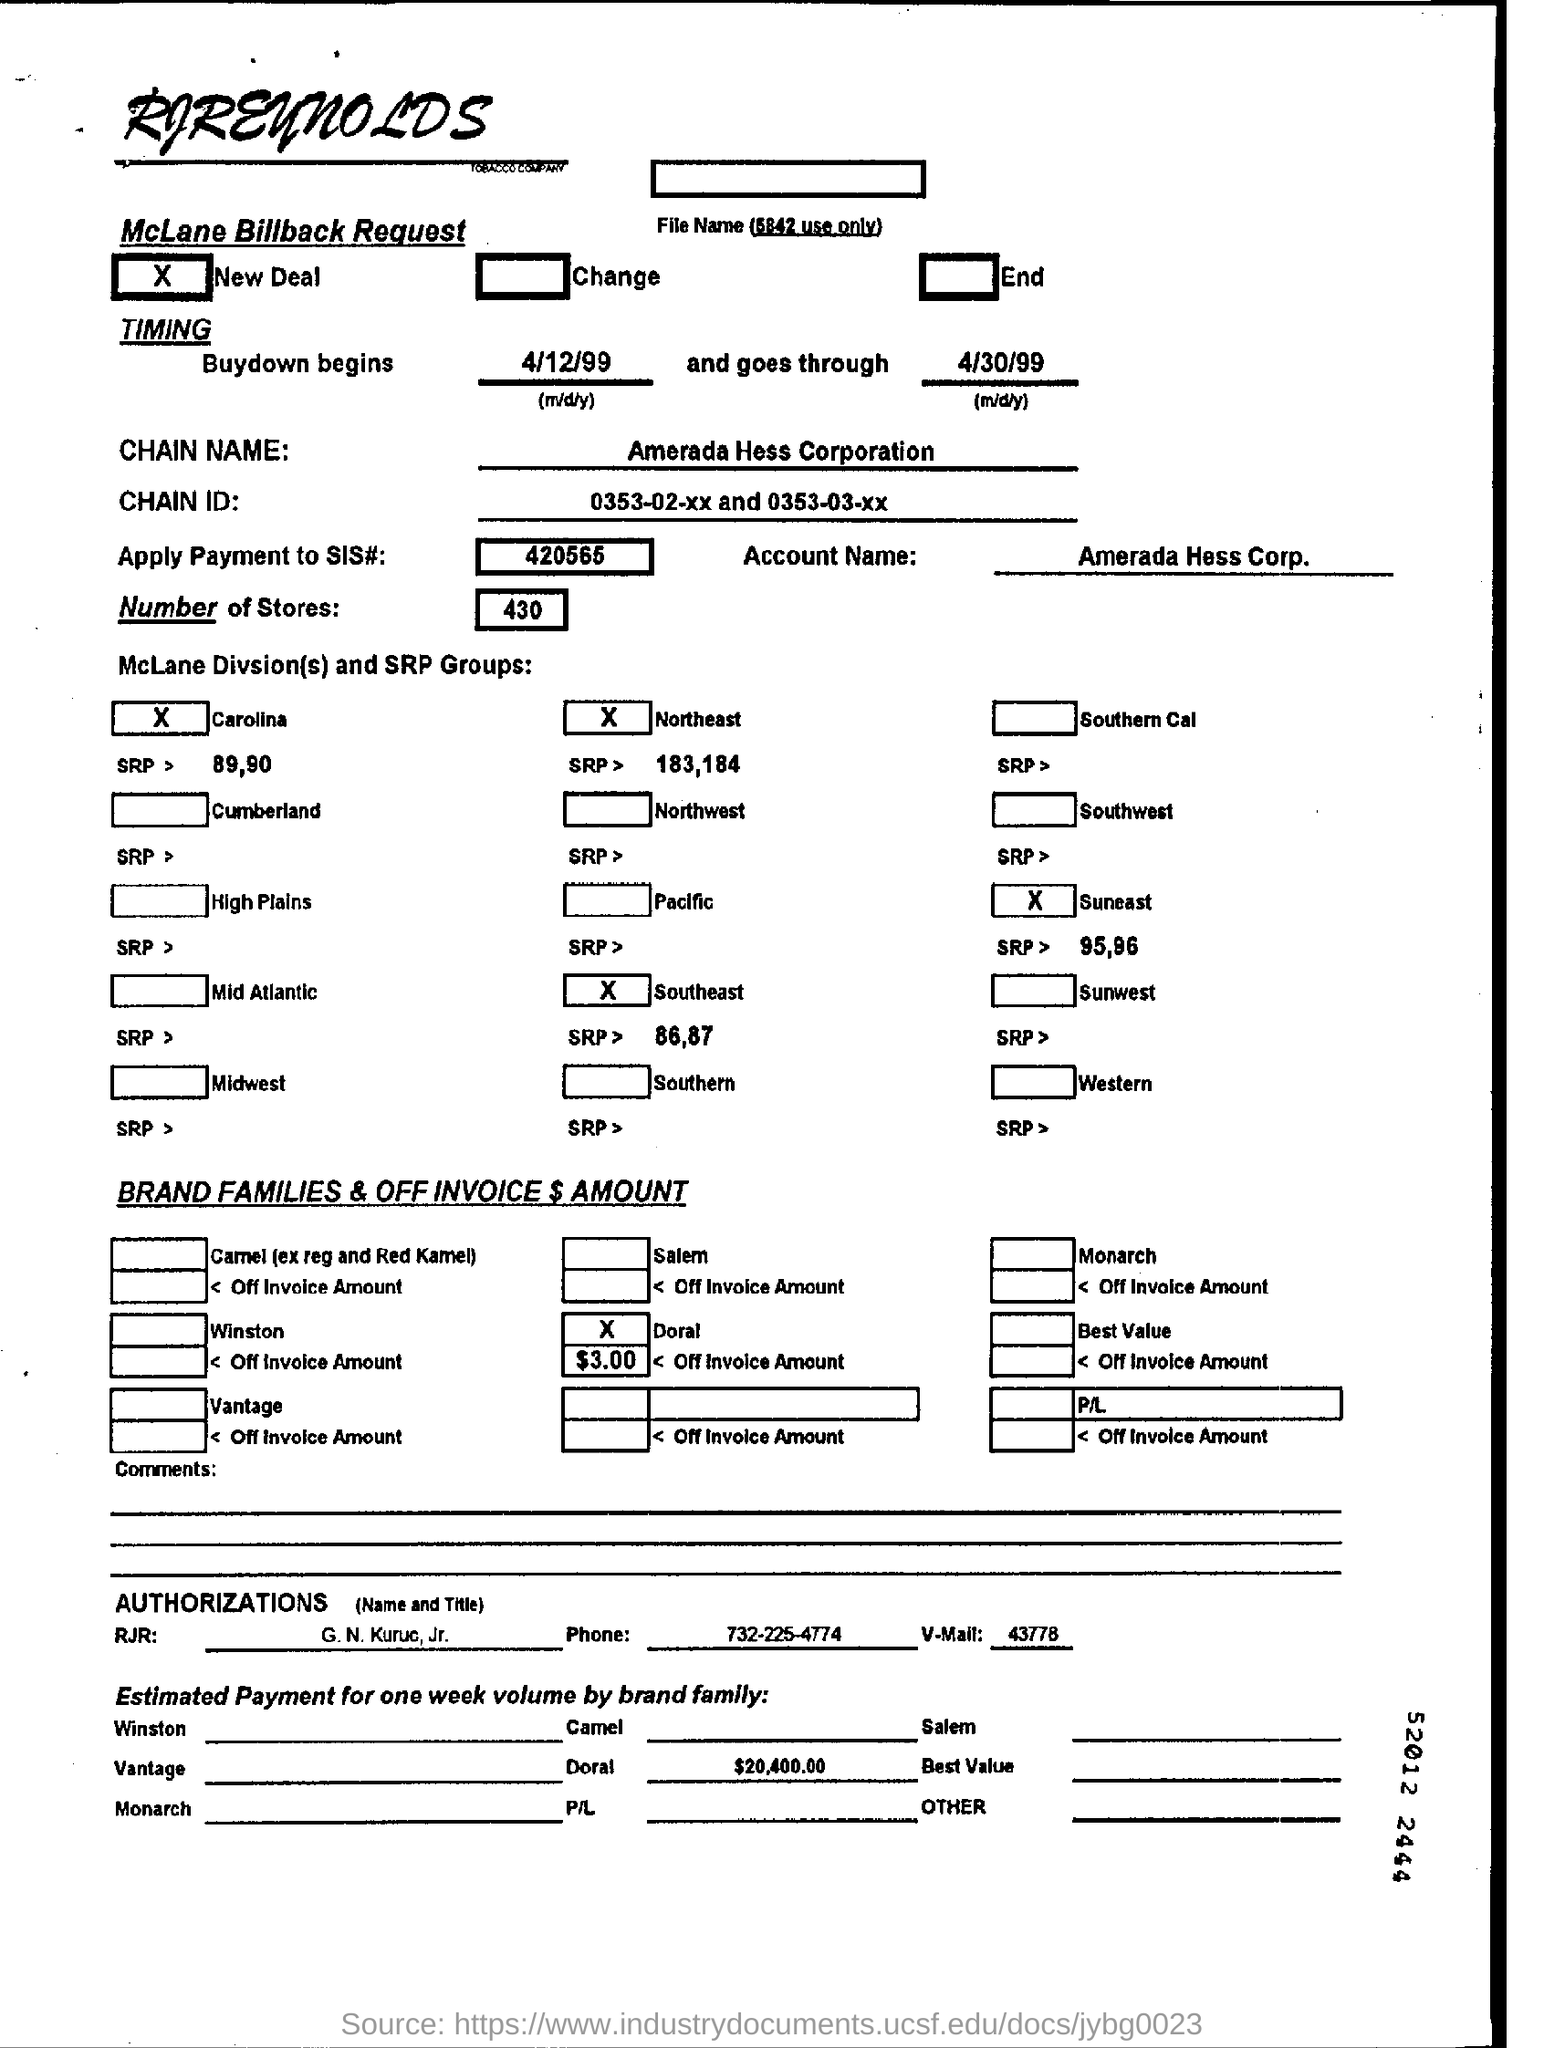How many number of stores are mentioned on the McLane billback request form?
Offer a terse response. 430. What is the chain name mentioned on the form?
Your answer should be compact. Amerada Hess Corporation. How much is the estimated payment for one week volume by Doral family?
Provide a short and direct response. 20,400.00. 